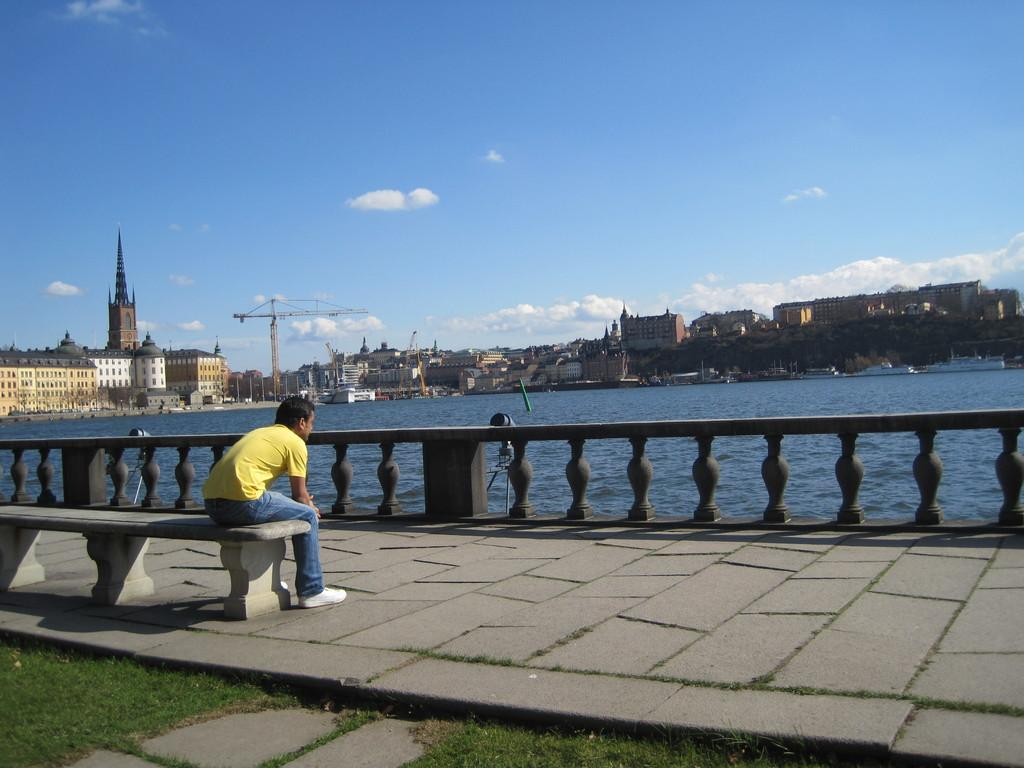What is the man in the image doing? The man is sitting on a bench in the image. What can be seen in the background of the image? There is a beach, a road, a building, a tree, and the sky visible in the background of the image. What is the condition of the sky in the image? The sky is visible in the background of the image, and it is covered with clouds. What type of wheel is the man using to transport the rose in the image? There is no wheel or rose present in the image; the man is simply sitting on a bench. 